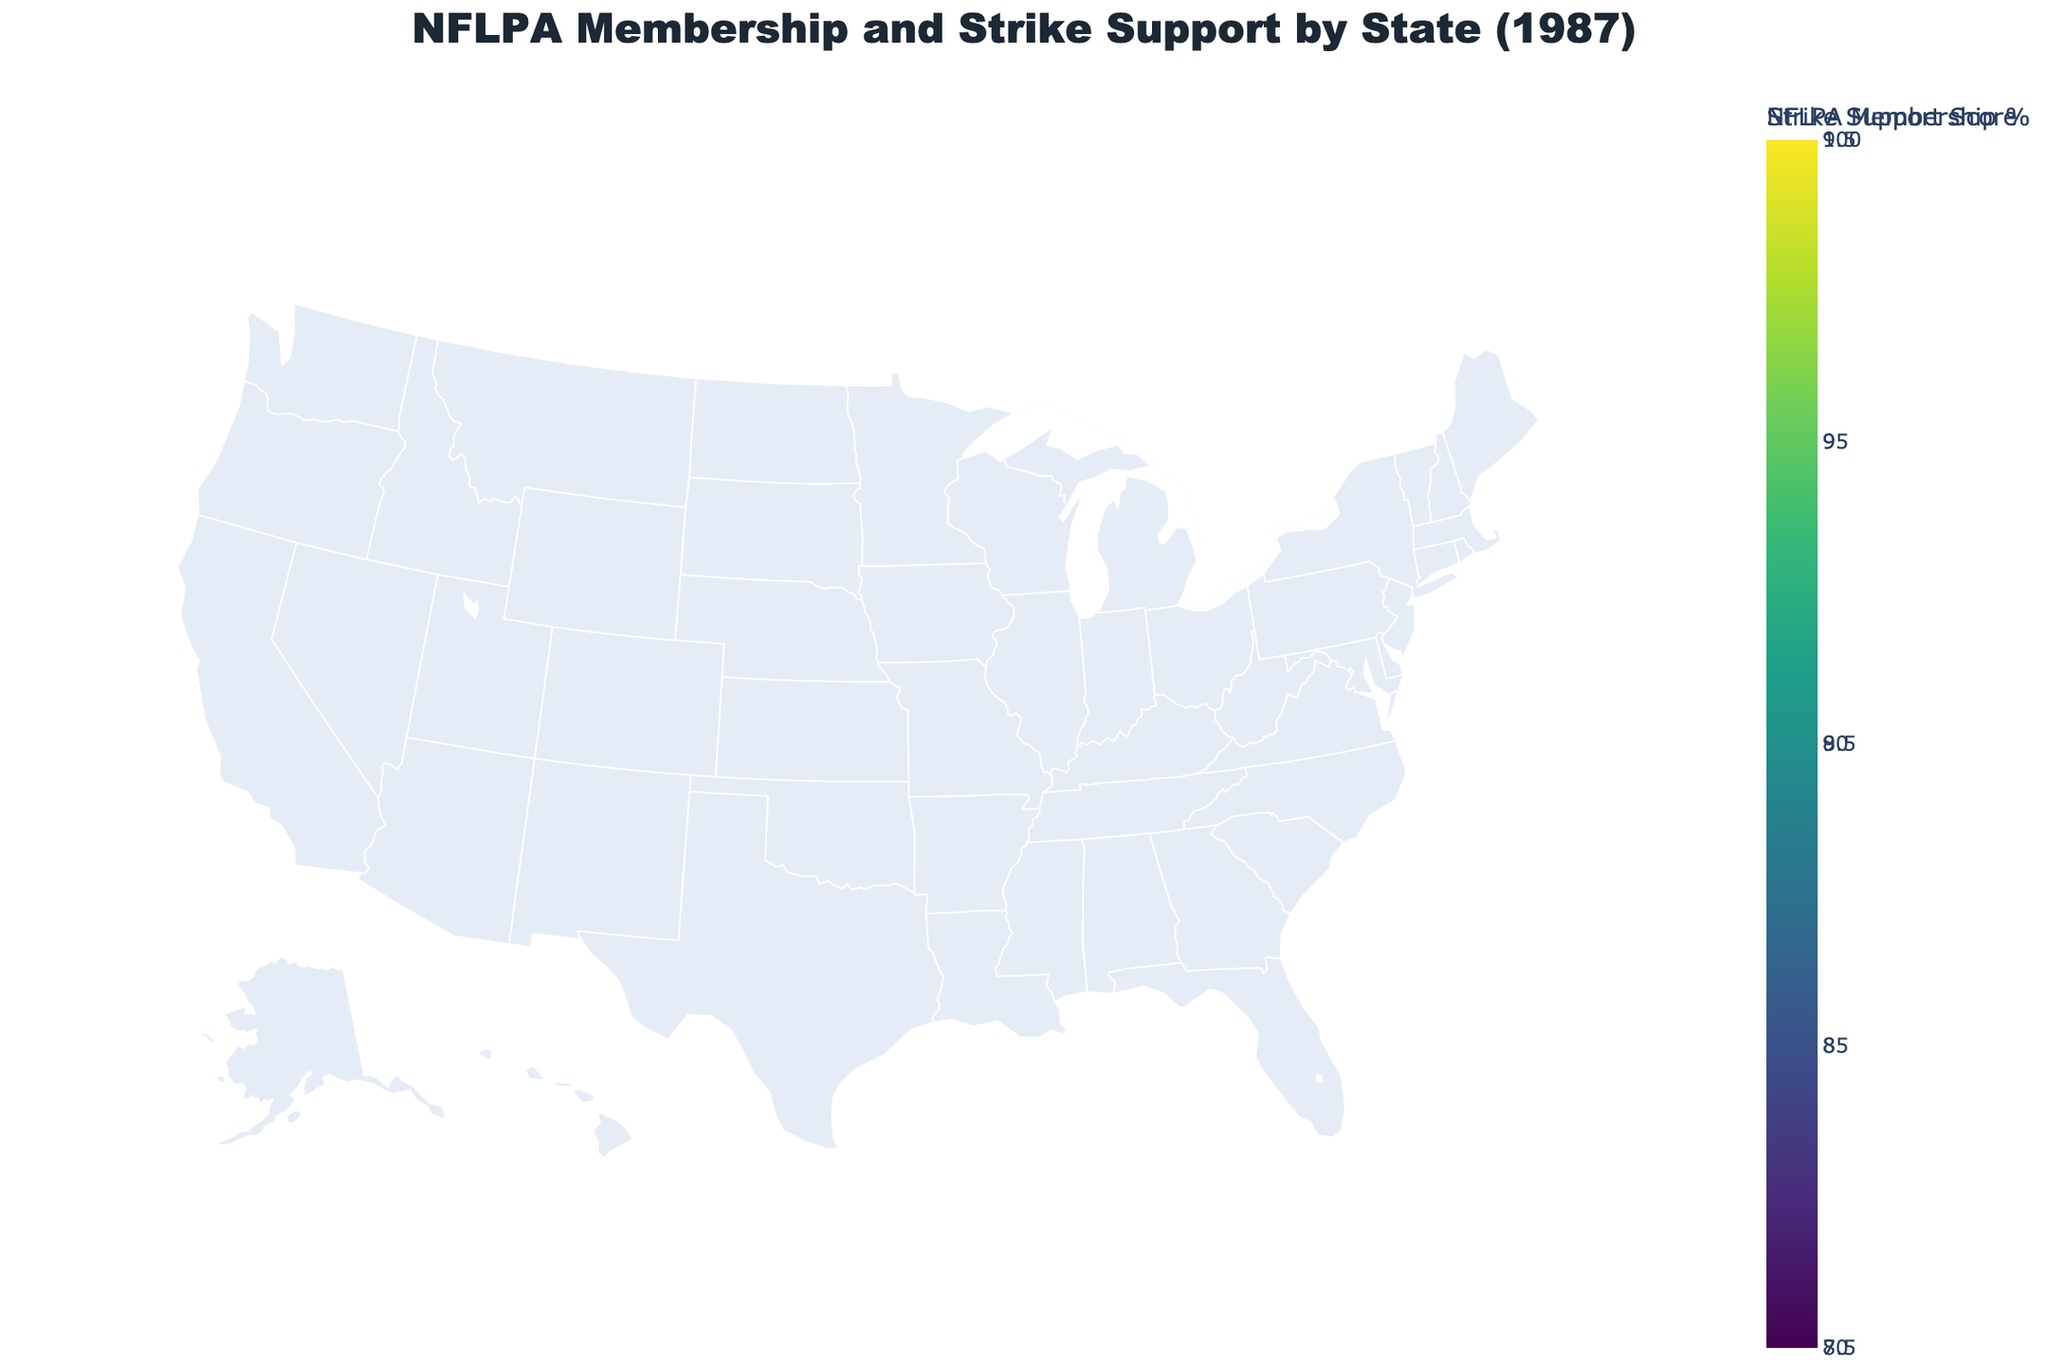What's the title of the figure? The title is displayed at the top, and it summarizes the main content of the figure.
Answer: NFLPA Membership and Strike Support by State (1987) What is the highest NFLPA Membership Percentage shown on the map? The color gradient indicates the range of NFLPA Membership Percentages, and the map legend helps identify the highest percentage. By examining the states with darker colors, New York has the highest percentage of 95%.
Answer: 95% Which state has the largest marker size, indicating the highest Strike Support Score? Marker sizes on the scatter plot correspond to Strike Support Scores. The largest marker, which is noticeably larger than the others, represents New York.
Answer: New York Which state has the lowest Strike Support Score among the ones displayed? By comparing the marker colors using the color scale, Arizona's marker color is the lightest, hence its Strike Support Score is the lowest at 7.7.
Answer: Arizona What's the average Strike Support Score across all states? Adding all Strike Support Scores and dividing by the number of states: (9.2 + 8.9 + 8.5 + 8.7 + 7.8 + 8.1 + 8.8 + 9.0 + 8.4 + 8.6 + 8.3 + 8.0 + 7.9 + 7.7 + 8.5) / 15 = 8.43.
Answer: 8.43 Which state shows a particularly high alignment between its NFLPA Membership Percentage and Strike Support Score? Generally, states with high NFLPA Membership Percentages should reflect higher Strike Support Scores. Massachusetts, with a membership percentage of 93% and support score of 9.0, shows high alignment.
Answer: Massachusetts How many states have an NFLPA Membership Percentage of 90% or higher? States such as New York, New Jersey, California, Illinois, and Massachusetts meet this criterion. Counting them gives: 5 states.
Answer: 5 states Compare the NFLPA Membership Percentages of Illinois and Ohio. Which state has a higher percentage and by how much? Illinois shows 91% and Ohio shows 87%. Subtracting Ohio's percentage from Illinois’ gives 91% - 87% = 4%.
Answer: Illinois by 4% Is there any state with an NFLPA Membership Percentage below 80% on the map? Reviewing the color gradient on the map, the lowest percentage is Arizona’s 81%. No state falls below 80%.
Answer: No 